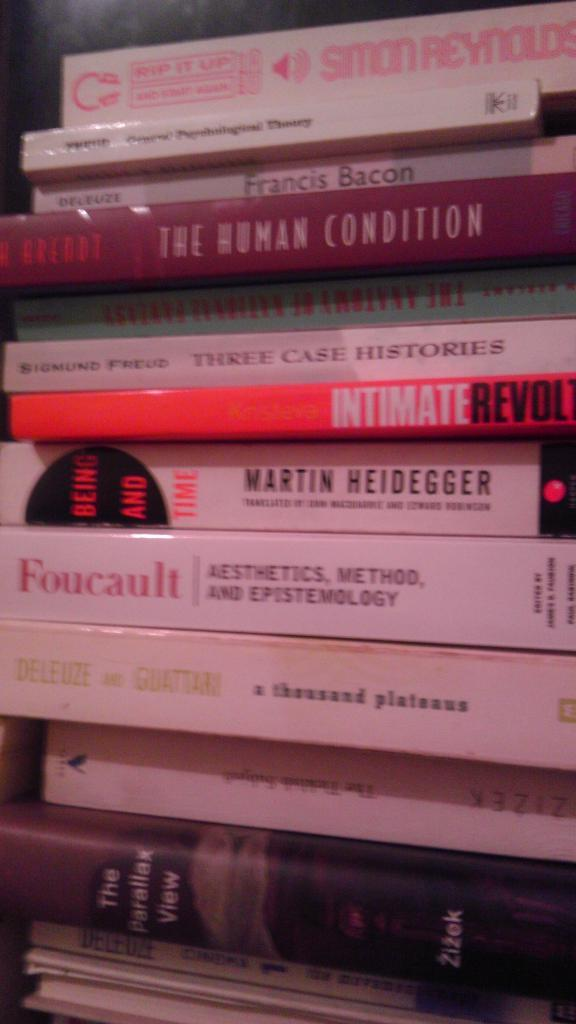<image>
Summarize the visual content of the image. The orange colored book in the middle is called Intimate Revolt 